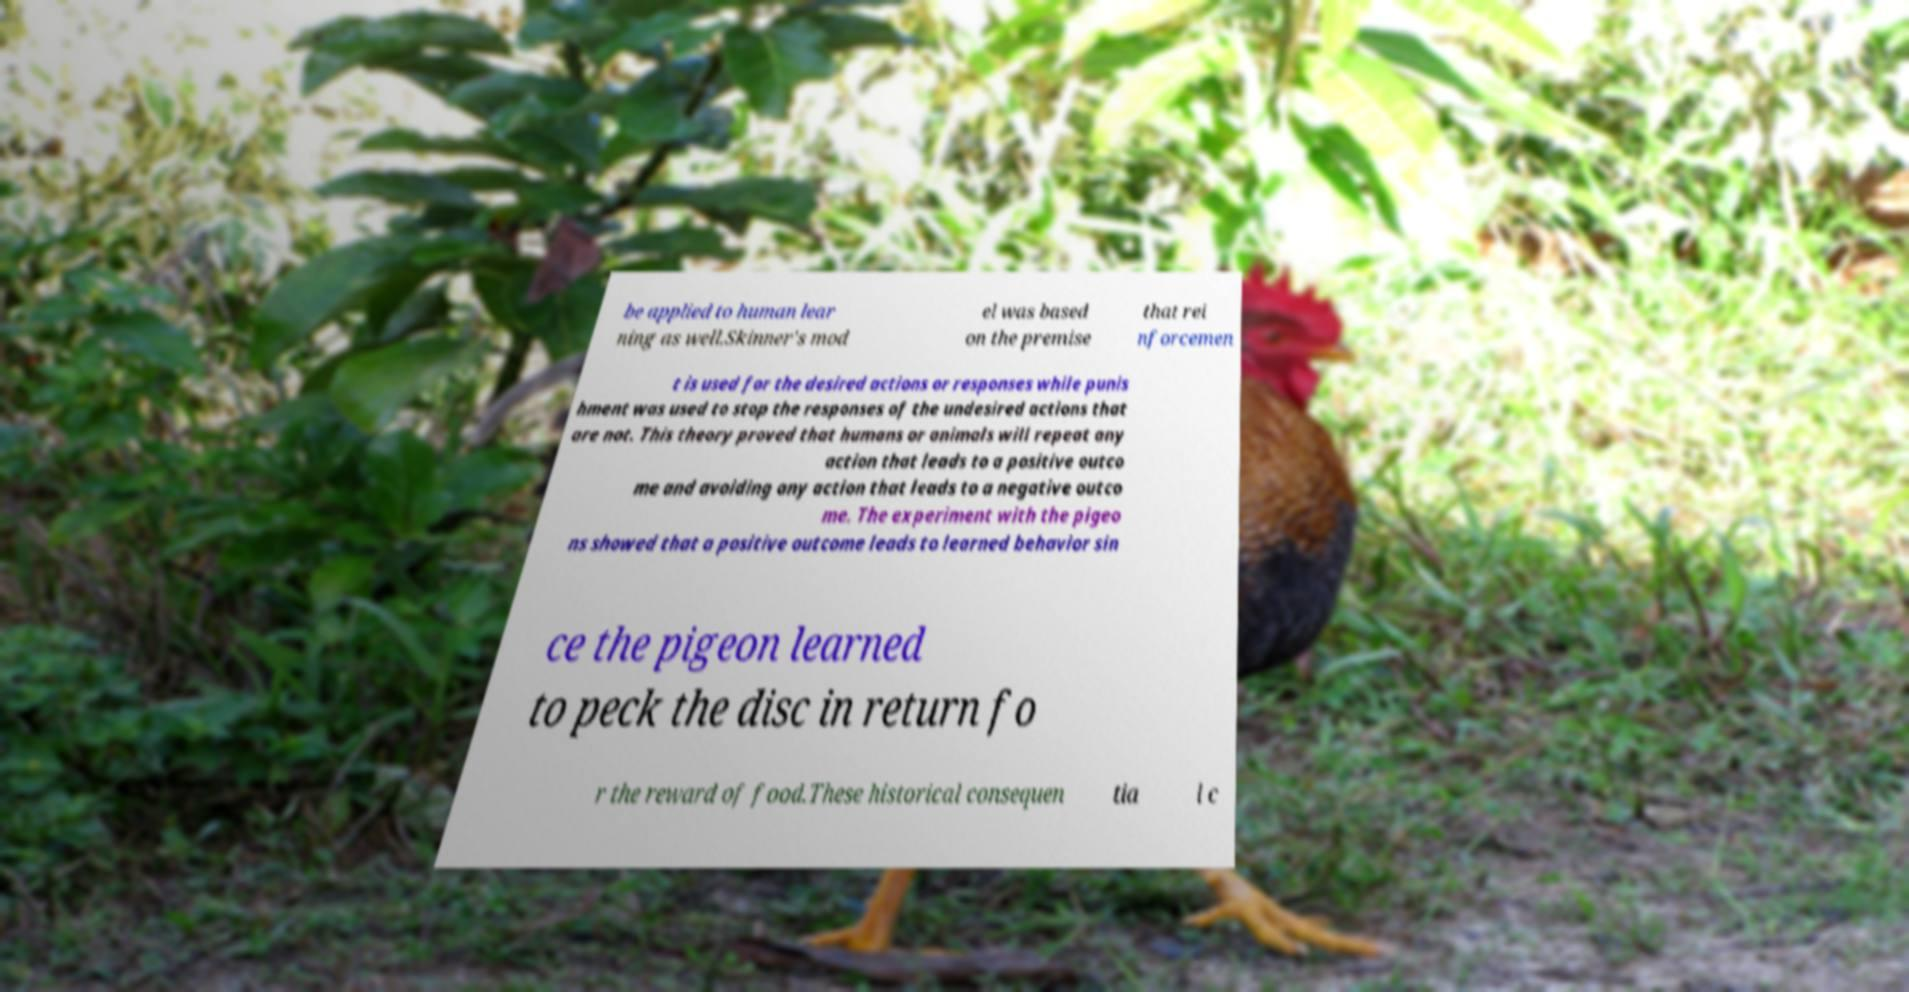For documentation purposes, I need the text within this image transcribed. Could you provide that? be applied to human lear ning as well.Skinner's mod el was based on the premise that rei nforcemen t is used for the desired actions or responses while punis hment was used to stop the responses of the undesired actions that are not. This theory proved that humans or animals will repeat any action that leads to a positive outco me and avoiding any action that leads to a negative outco me. The experiment with the pigeo ns showed that a positive outcome leads to learned behavior sin ce the pigeon learned to peck the disc in return fo r the reward of food.These historical consequen tia l c 